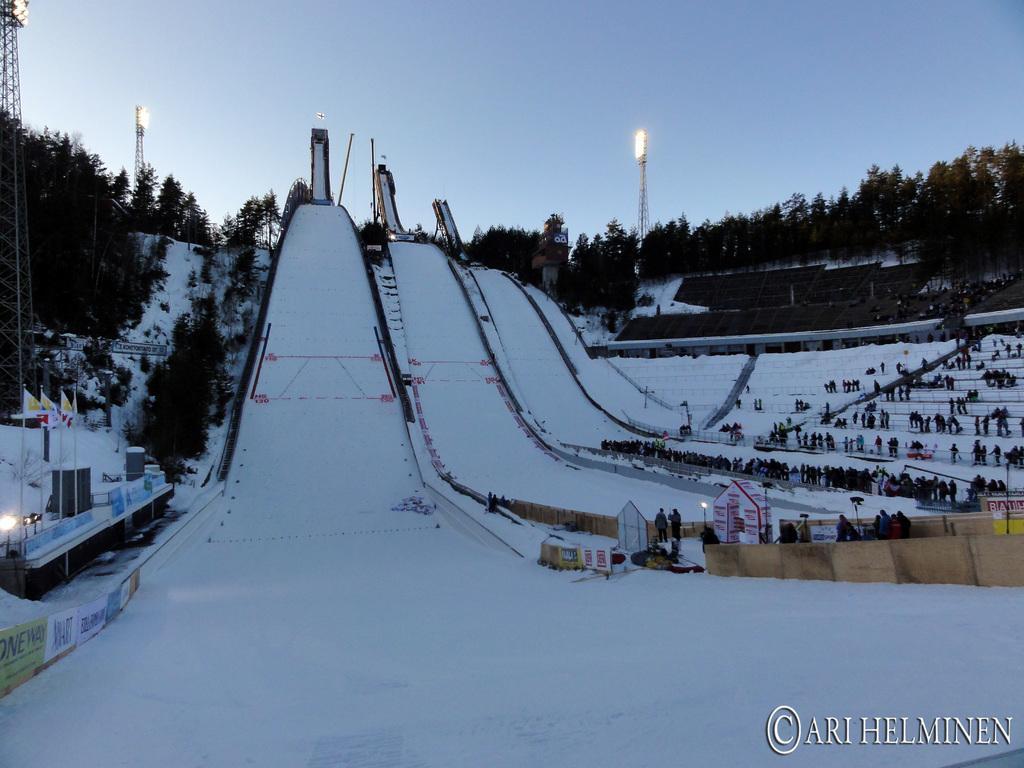Describe this image in one or two sentences. This is an outside view. In this image I can see the ski stadium. On the right side, I can see people standing on the ground. In the background there are many trees and also I can see the transformers. On the left side there is a building and few light poles and also there are few flags. On the ground, I can see the snow. At the top of the image I can see the sky. In the bottom right hand-corner there is some text. 